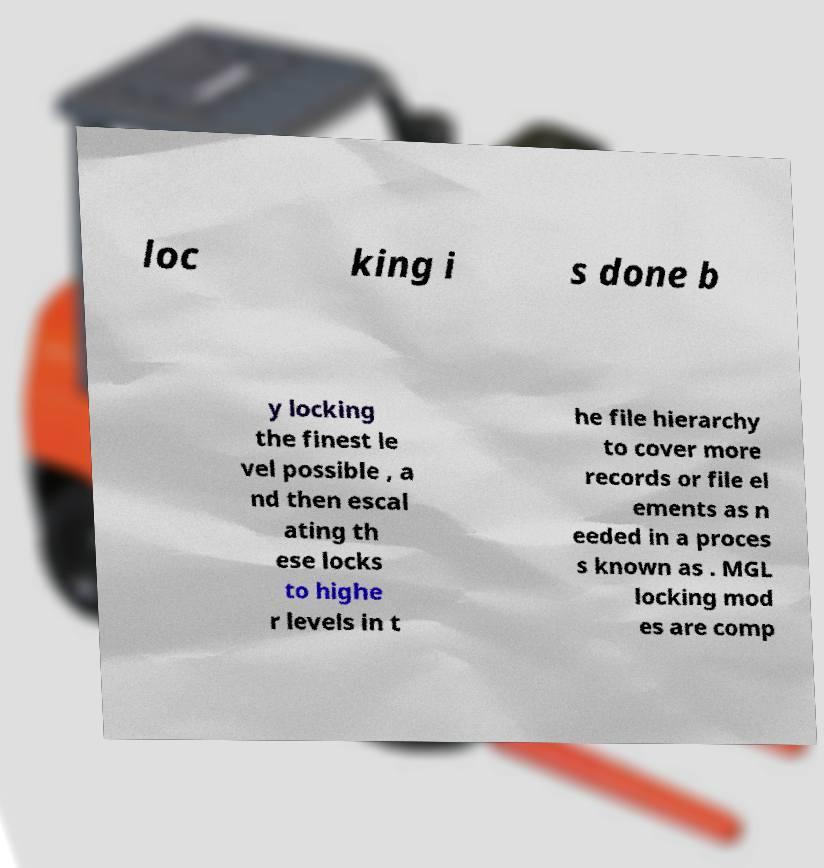Could you extract and type out the text from this image? loc king i s done b y locking the finest le vel possible , a nd then escal ating th ese locks to highe r levels in t he file hierarchy to cover more records or file el ements as n eeded in a proces s known as . MGL locking mod es are comp 